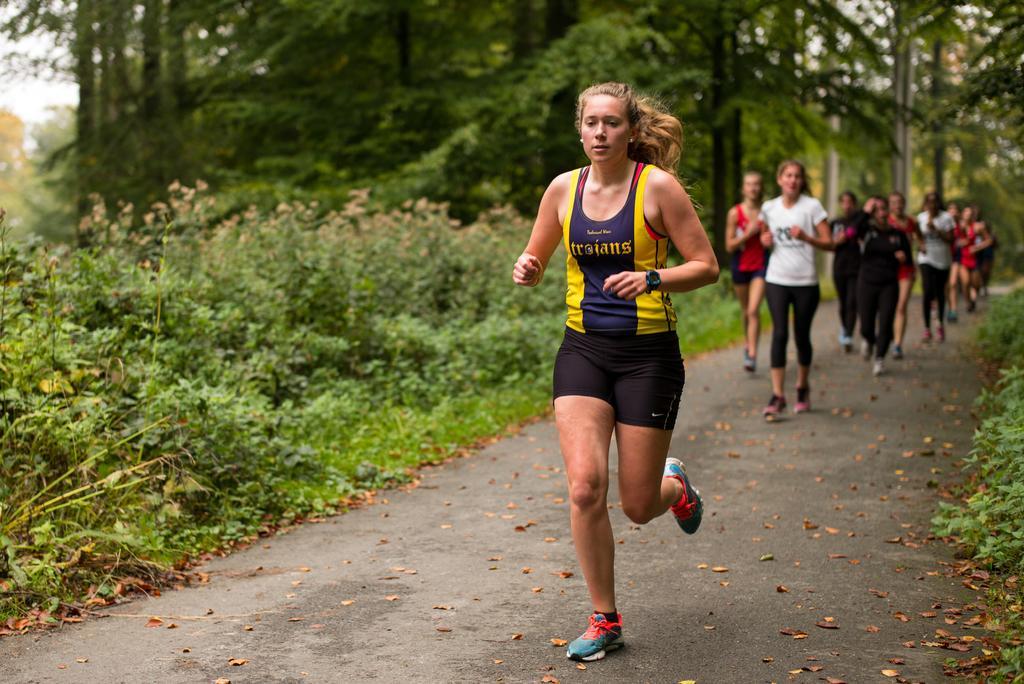How would you summarize this image in a sentence or two? In this image there are persons jogging on the road. On both sides of the road there are many trees. 